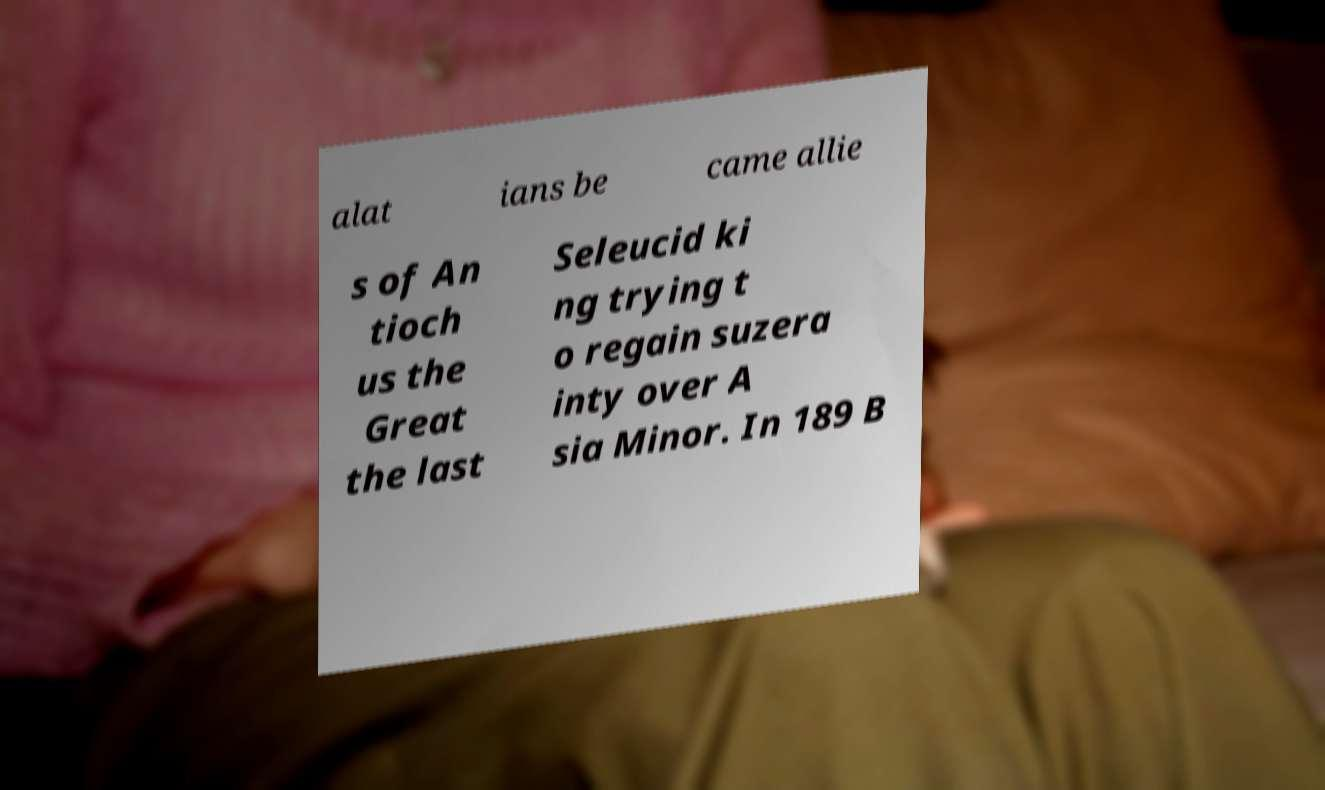For documentation purposes, I need the text within this image transcribed. Could you provide that? alat ians be came allie s of An tioch us the Great the last Seleucid ki ng trying t o regain suzera inty over A sia Minor. In 189 B 